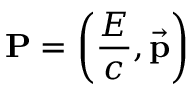Convert formula to latex. <formula><loc_0><loc_0><loc_500><loc_500>P = \left ( { \frac { E } { c } } , { \vec { p } } \right )</formula> 